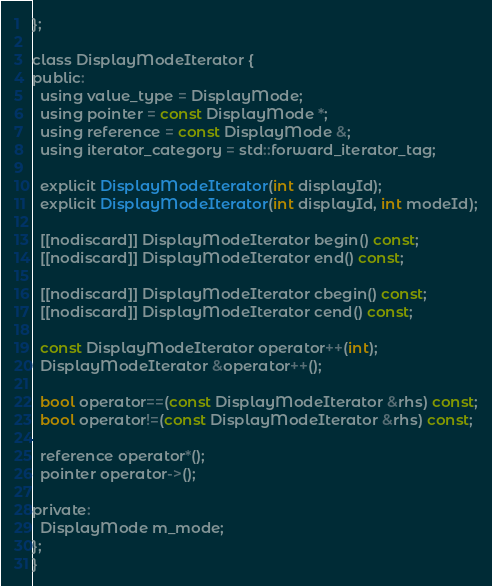Convert code to text. <code><loc_0><loc_0><loc_500><loc_500><_C_>};

class DisplayModeIterator {
public:
  using value_type = DisplayMode;
  using pointer = const DisplayMode *;
  using reference = const DisplayMode &;
  using iterator_category = std::forward_iterator_tag;

  explicit DisplayModeIterator(int displayId);
  explicit DisplayModeIterator(int displayId, int modeId);

  [[nodiscard]] DisplayModeIterator begin() const;
  [[nodiscard]] DisplayModeIterator end() const;

  [[nodiscard]] DisplayModeIterator cbegin() const;
  [[nodiscard]] DisplayModeIterator cend() const;

  const DisplayModeIterator operator++(int);
  DisplayModeIterator &operator++();

  bool operator==(const DisplayModeIterator &rhs) const;
  bool operator!=(const DisplayModeIterator &rhs) const;

  reference operator*();
  pointer operator->();

private:
  DisplayMode m_mode;
};
}</code> 